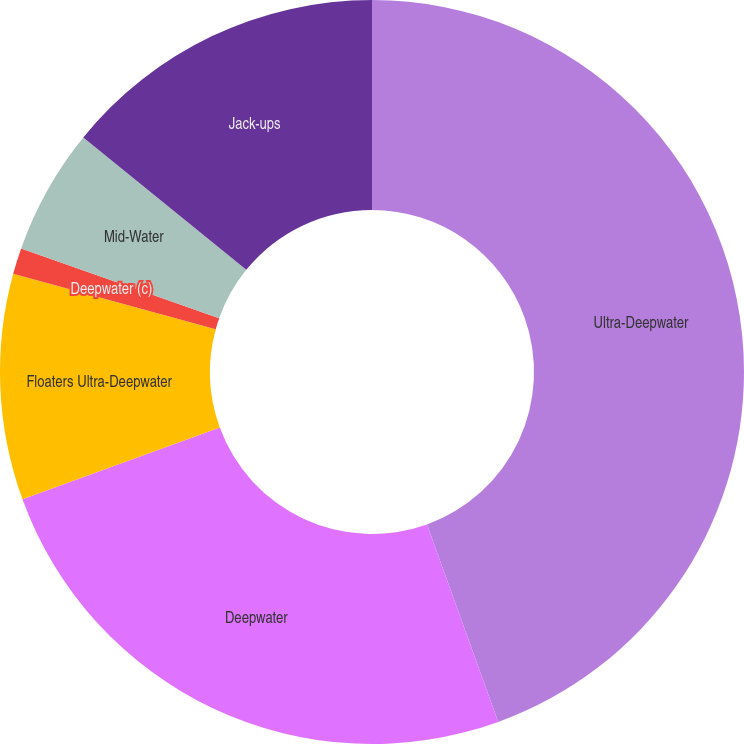<chart> <loc_0><loc_0><loc_500><loc_500><pie_chart><fcel>Ultra-Deepwater<fcel>Deepwater<fcel>Floaters Ultra-Deepwater<fcel>Deepwater (c)<fcel>Mid-Water<fcel>Jack-ups<nl><fcel>44.49%<fcel>24.95%<fcel>9.81%<fcel>1.14%<fcel>5.47%<fcel>14.14%<nl></chart> 